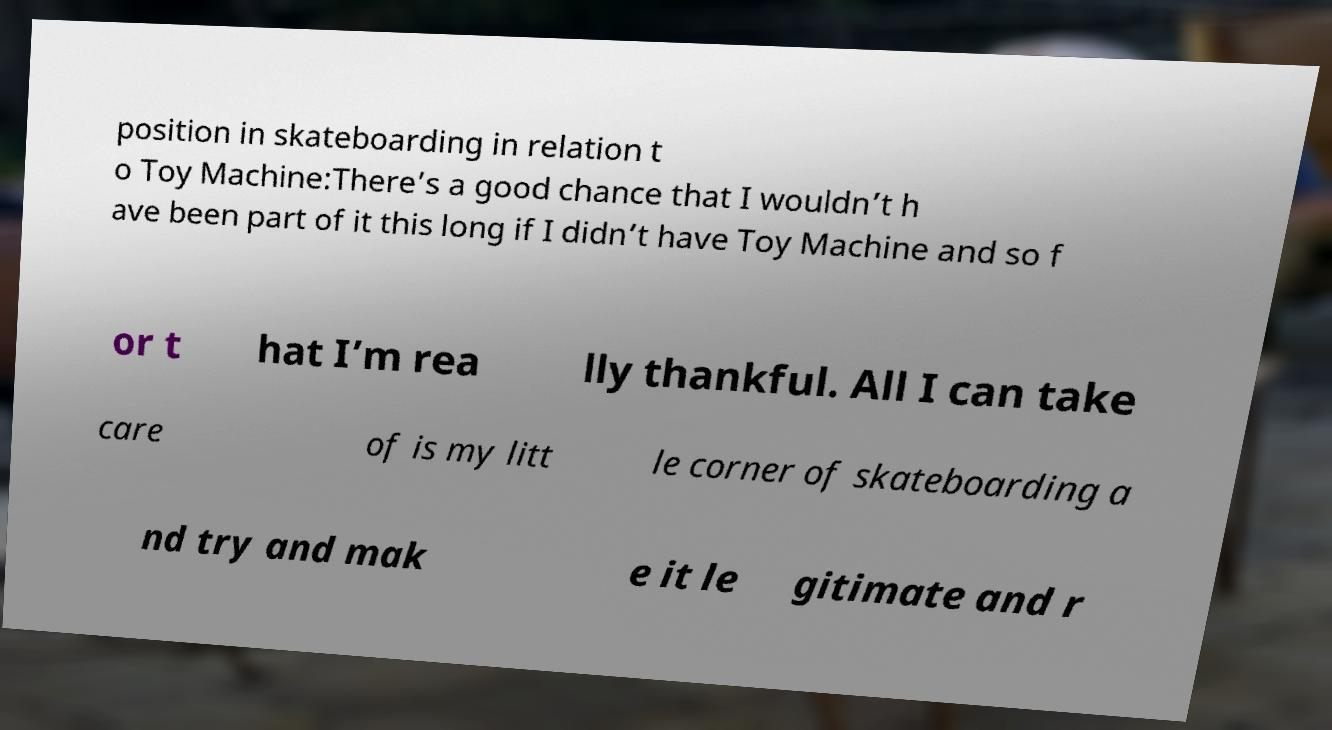Could you assist in decoding the text presented in this image and type it out clearly? position in skateboarding in relation t o Toy Machine:There’s a good chance that I wouldn’t h ave been part of it this long if I didn’t have Toy Machine and so f or t hat I’m rea lly thankful. All I can take care of is my litt le corner of skateboarding a nd try and mak e it le gitimate and r 